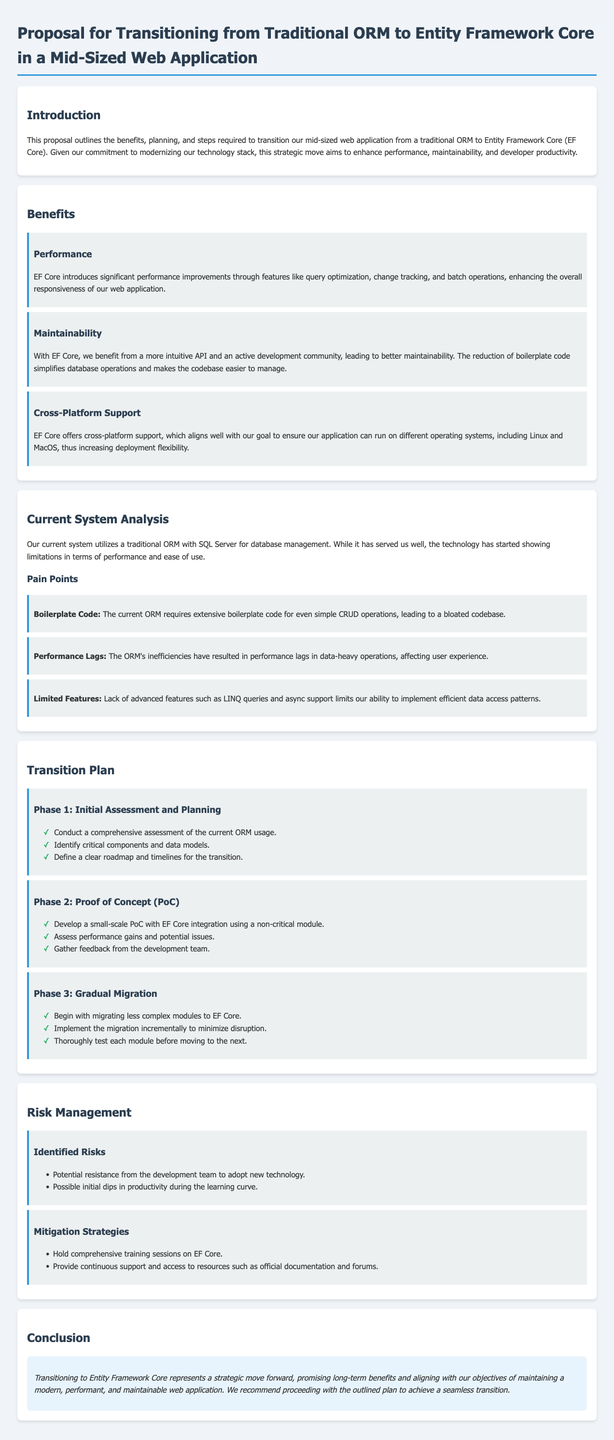What are the three main benefits of EF Core? The document lists the benefits as performance, maintainability, and cross-platform support.
Answer: performance, maintainability, cross-platform support What phase involves developing a PoC? The second phase is specifically focused on developing a small-scale PoC to assess EF Core's integration.
Answer: Phase 2: Proof of Concept What pain point is associated with performance lags? The document describes performance lags due to inefficiencies in the current ORM, affecting user experience.
Answer: Performance Lags What is the conclusion regarding the transition to EF Core? The conclusion emphasizes that transitioning to EF Core represents a strategic move that promises long-term benefits.
Answer: strategic move forward, long-term benefits How many phases are outlined in the transition plan? The transition plan details three distinct phases for migrating to EF Core.
Answer: Three phases 